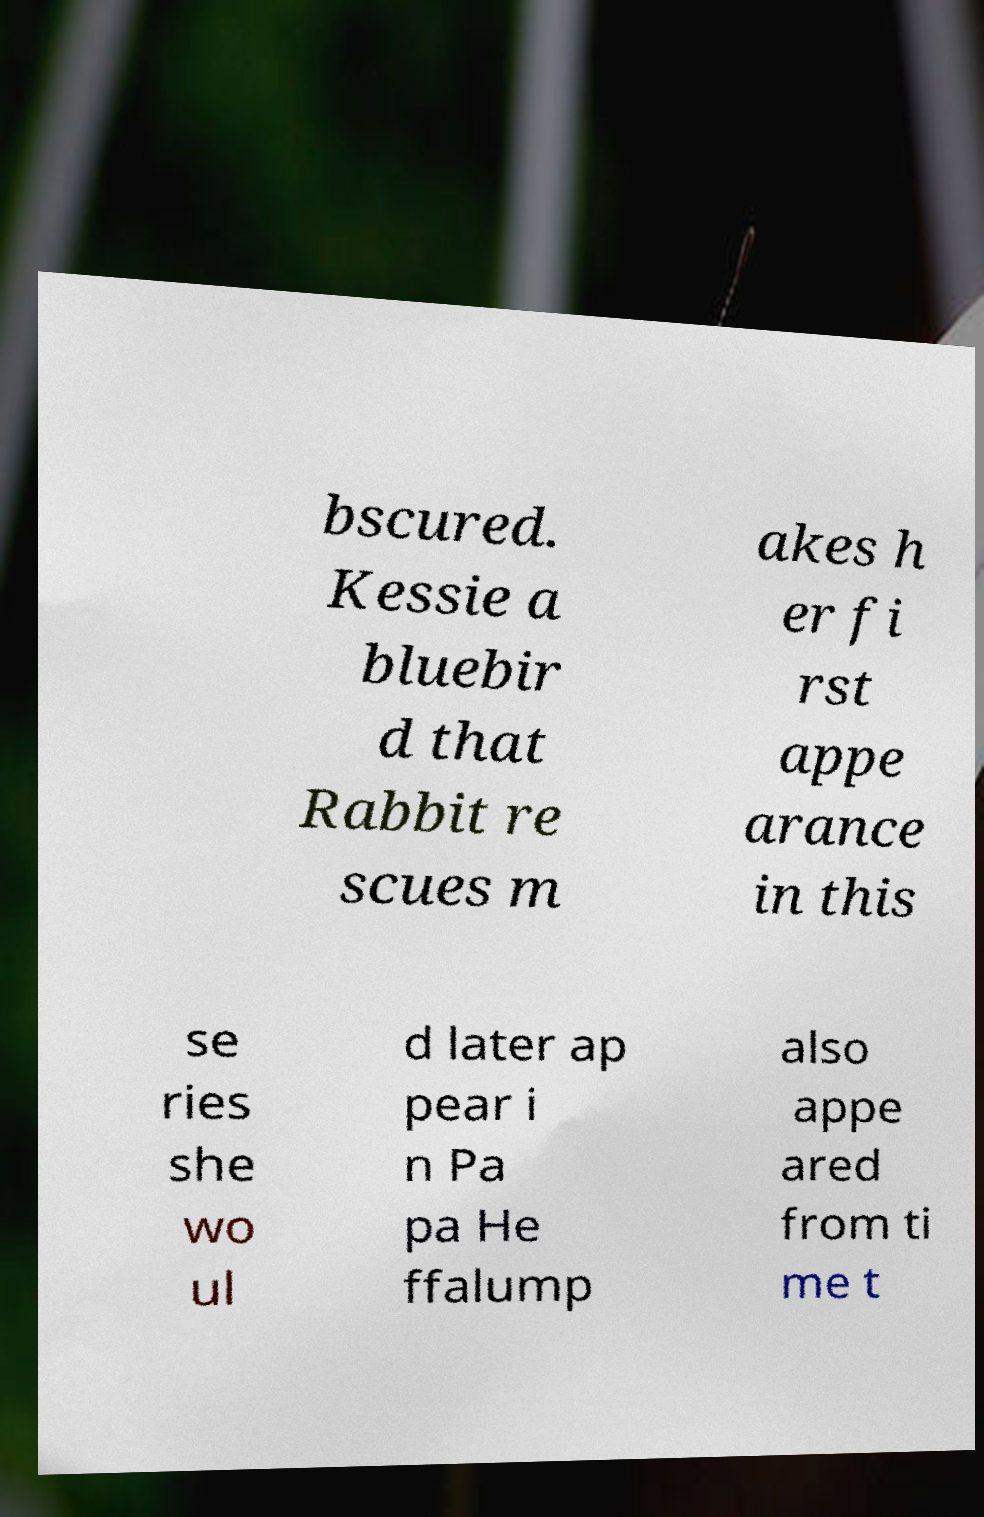I need the written content from this picture converted into text. Can you do that? bscured. Kessie a bluebir d that Rabbit re scues m akes h er fi rst appe arance in this se ries she wo ul d later ap pear i n Pa pa He ffalump also appe ared from ti me t 